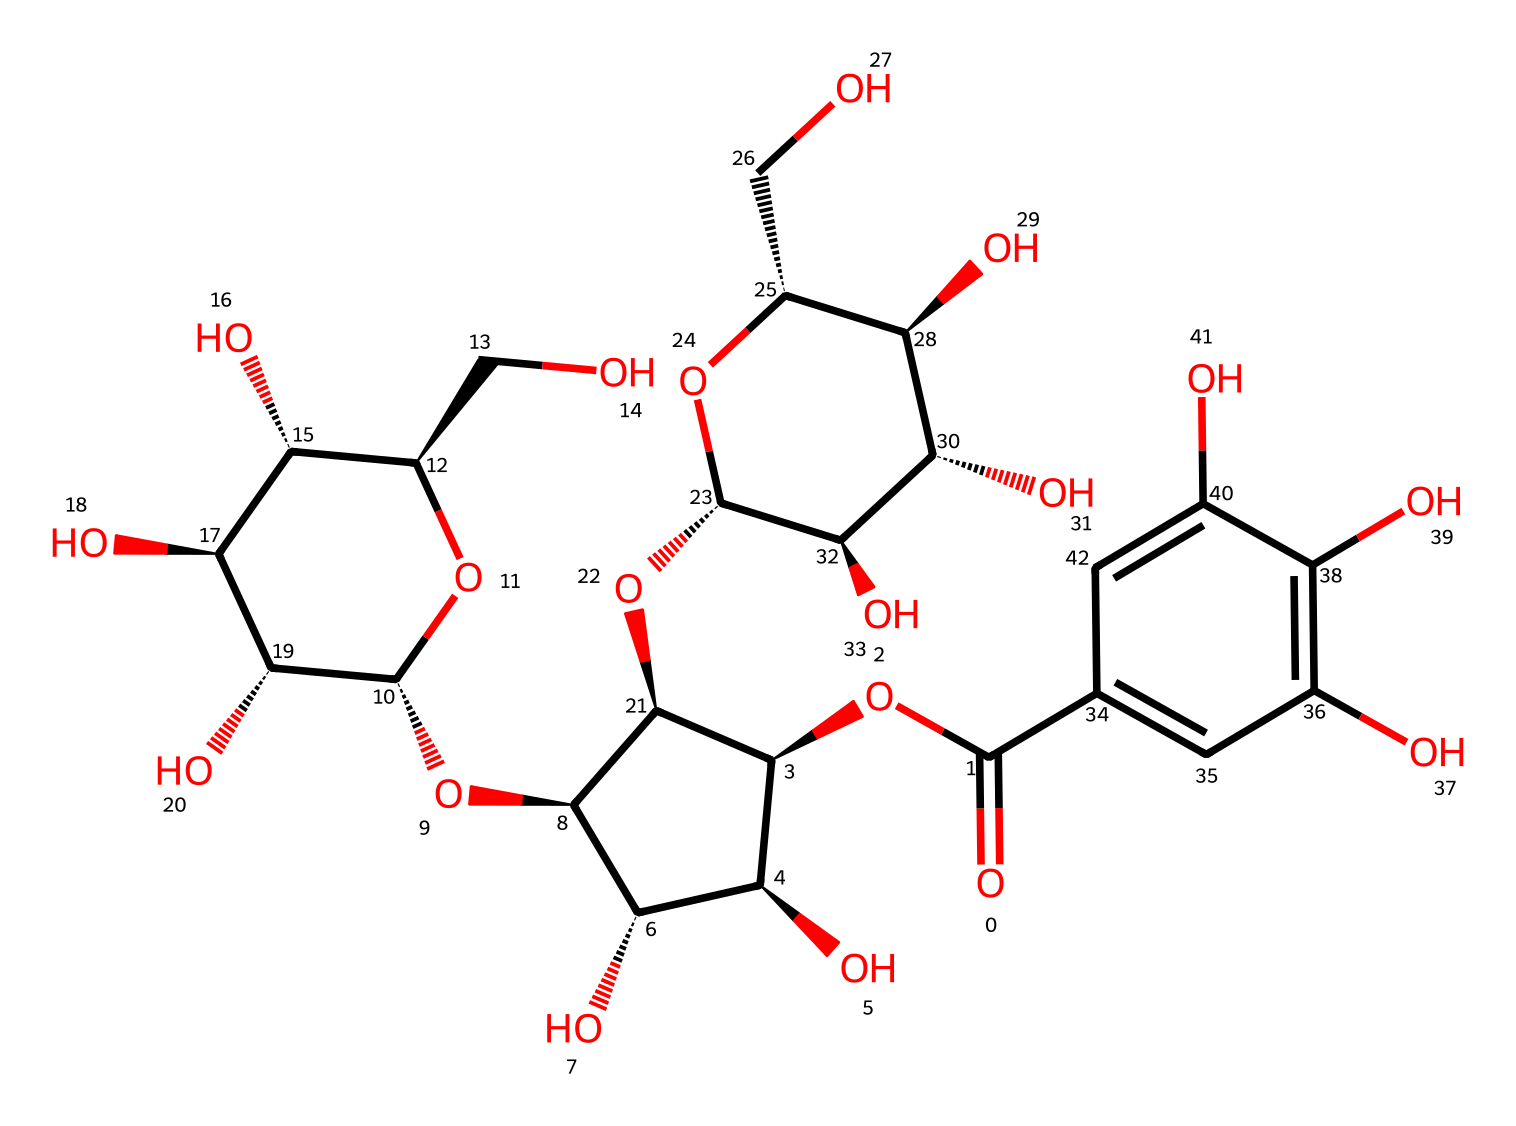How many carbon atoms are in tannic acid? By analyzing the SMILES representation, we can identify the number of carbon (C) atoms present. Each distinct carbon in the structure contributes to the total count. The breakdown shows there are several instances of C in the compounds indicated.
Answer: 21 What is the molecular weight of tannic acid? While the exact molecular weight view isn't directly viewable from the SMILES, we can derive it by summing up the individual atomic weights of each atom in the chemical formula. This provides us an accurate molecular weight for tannic acid after proper calculations.
Answer: 1700 What functional groups are present in tannic acid? A close examination of the chemical structure reveals multiple hydroxyl (-OH) groups and ester (−O−) groups. These functional groups are characteristic of phenols and play a crucial role in the chemical behavior of tannic acid.
Answer: hydroxyl and ester How many hydroxyl groups are present in tannic acid? The visual inspection of the chemical structure shows multiple -OH groups. Counting these reveals the number of hydroxyl groups directly contributes to the hydrophilicity and reactivity of tannic acid.
Answer: 10 What is the characteristic property of phenolic compounds reflected in tannic acid? Phenolic compounds are known for their antioxidative properties. The structure of tannic acid includes hydroxyl groups, allowing it to scavenge free radicals effectively, highlighting its phenolic characteristics.
Answer: antioxidative properties What is the significance of the aromatic ring in tannic acid? The presence of the aromatic ring in the structure is indicative of stability and pi-electron delocalization, which also contributes to the chemical reactivity and solubility properties of tannic acid.
Answer: stability and reactivity What type of reaction might tannic acid participate in due to its functional groups? Given the presence of multiple reactive hydroxyl groups, tannic acid is likely to participate in condensation reactions, forming esters or ethers as it can react with various alcohols.
Answer: condensation reactions 